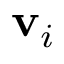<formula> <loc_0><loc_0><loc_500><loc_500>v _ { i }</formula> 